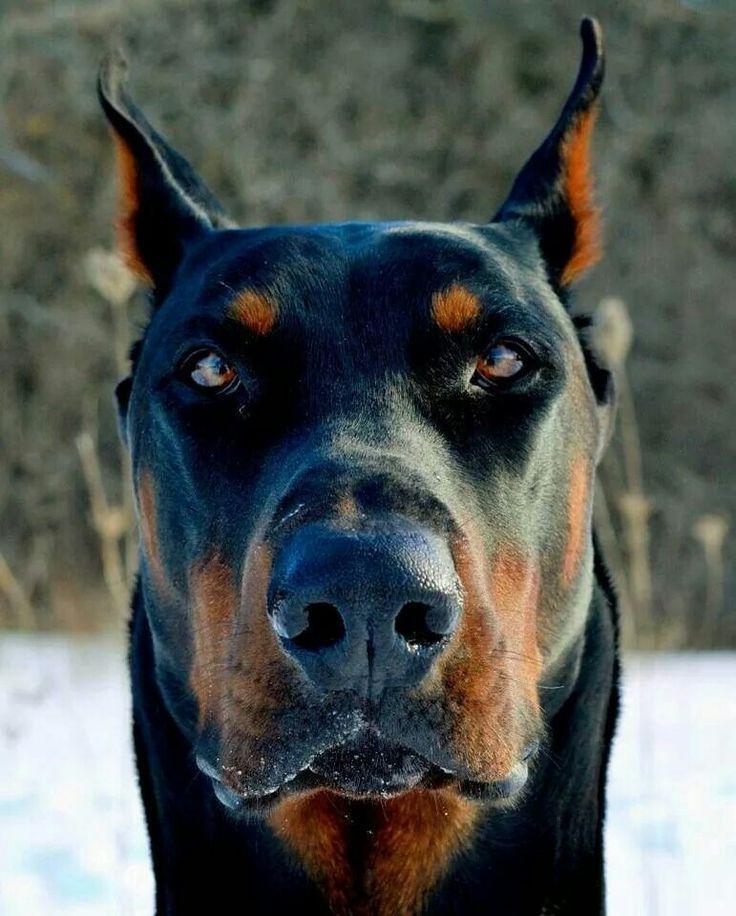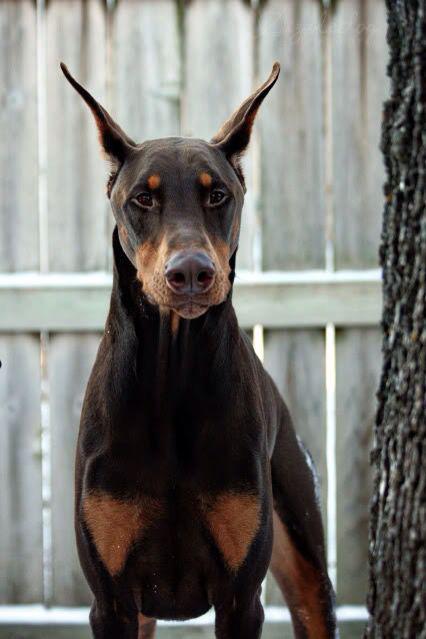The first image is the image on the left, the second image is the image on the right. Examine the images to the left and right. Is the description "Each image shows one forward-facing adult doberman with pointy erect ears." accurate? Answer yes or no. Yes. The first image is the image on the left, the second image is the image on the right. Given the left and right images, does the statement "The ears of two dobermans are sticking straight up." hold true? Answer yes or no. Yes. 